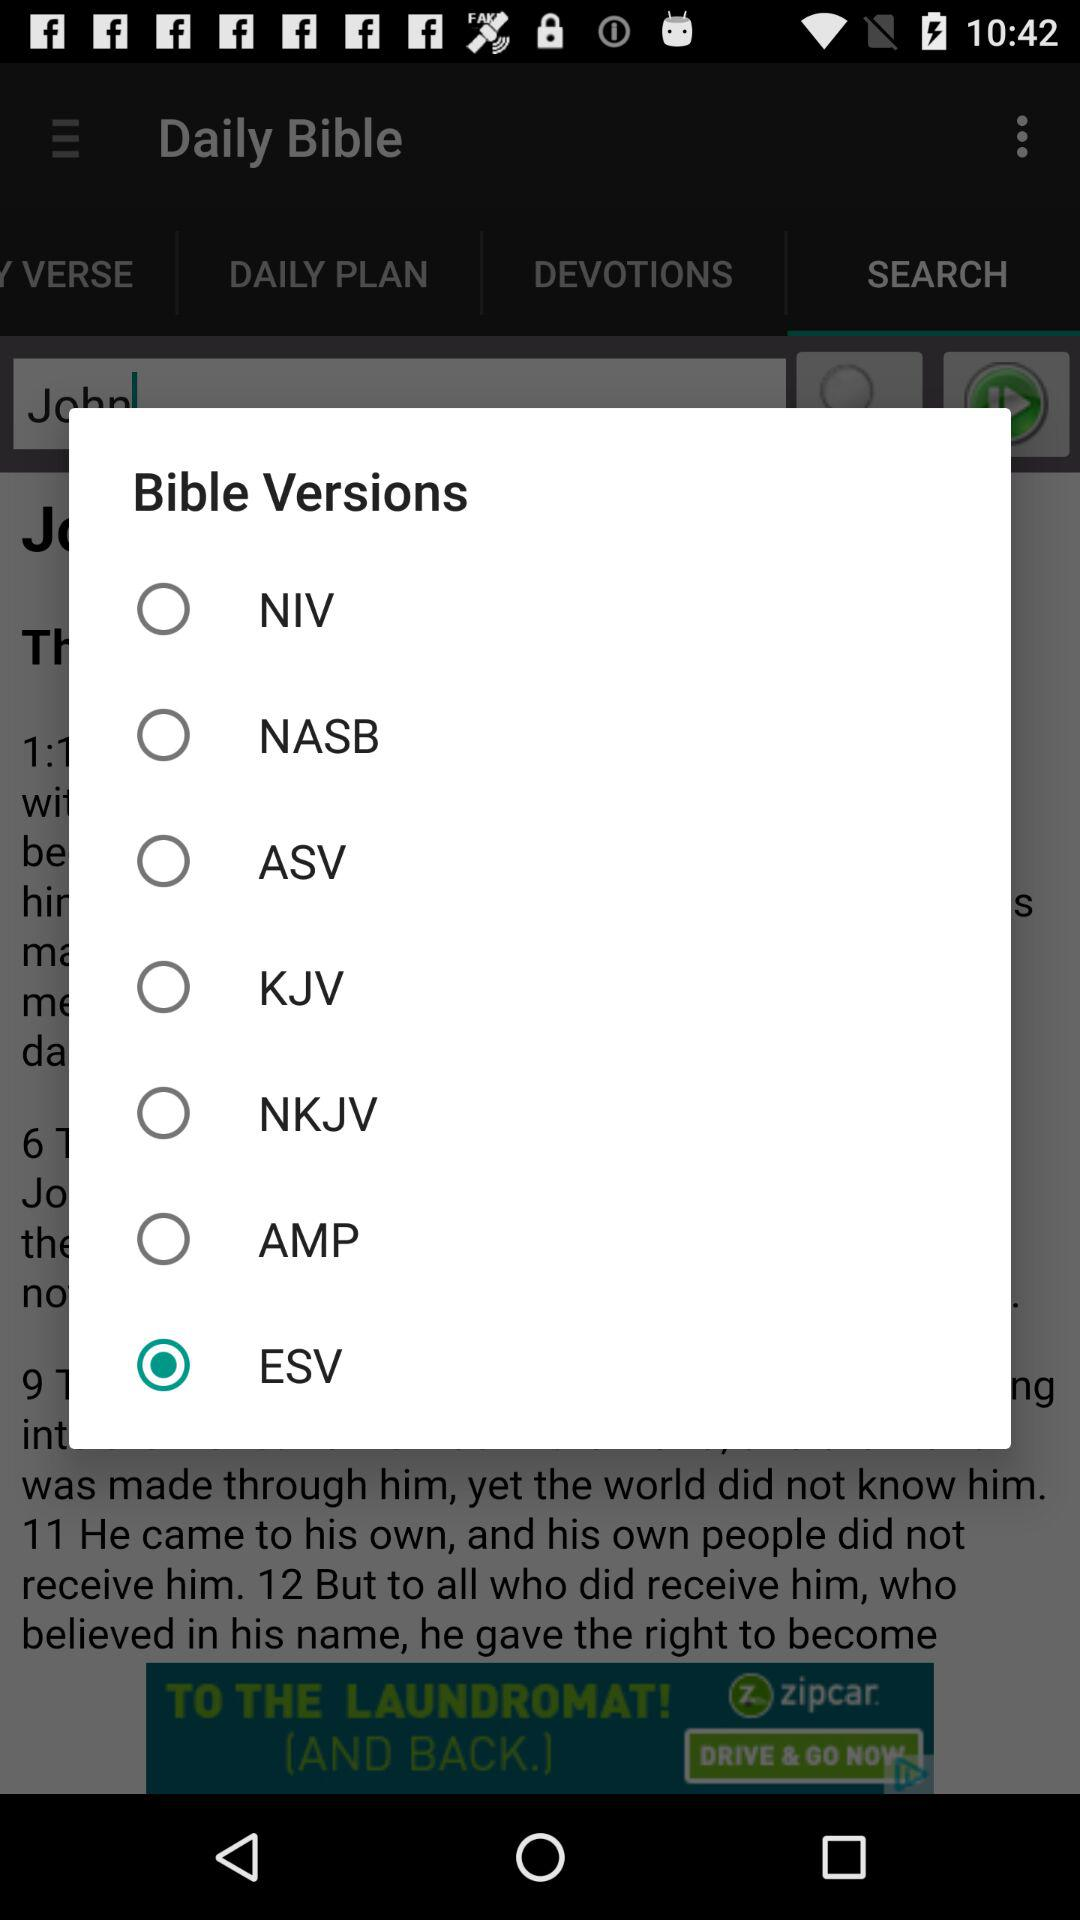Which "Bible Versions" were not selected? The mentioned non-selected options were "NIV", "NASB", "ASV", "KJV", "NKJV", and "AMP". 